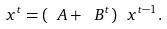Convert formula to latex. <formula><loc_0><loc_0><loc_500><loc_500>\ x ^ { t } = ( \ A + \ B ^ { t } ) \ x ^ { t - 1 } .</formula> 